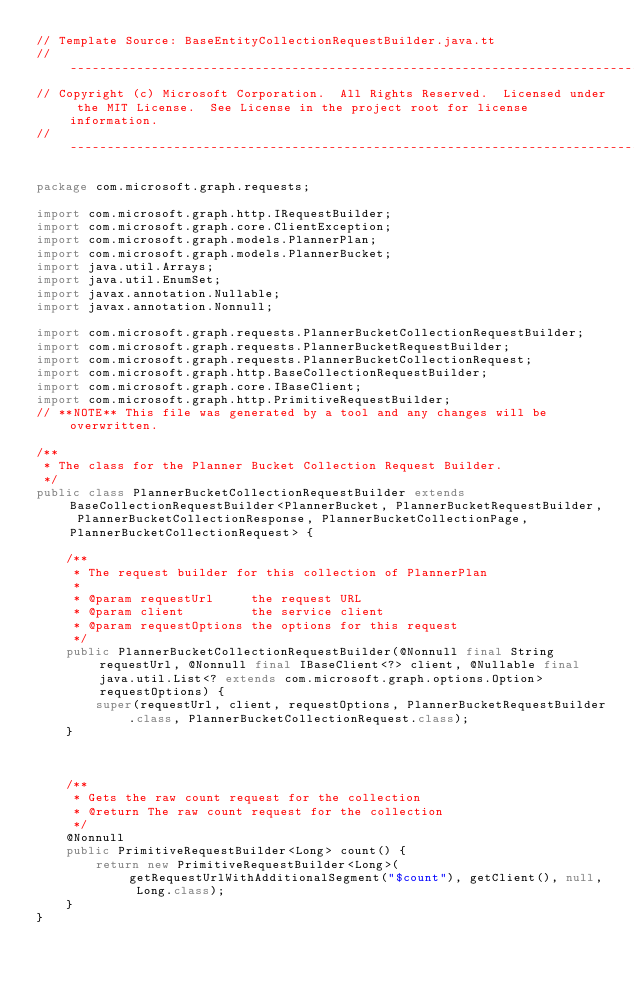<code> <loc_0><loc_0><loc_500><loc_500><_Java_>// Template Source: BaseEntityCollectionRequestBuilder.java.tt
// ------------------------------------------------------------------------------
// Copyright (c) Microsoft Corporation.  All Rights Reserved.  Licensed under the MIT License.  See License in the project root for license information.
// ------------------------------------------------------------------------------

package com.microsoft.graph.requests;

import com.microsoft.graph.http.IRequestBuilder;
import com.microsoft.graph.core.ClientException;
import com.microsoft.graph.models.PlannerPlan;
import com.microsoft.graph.models.PlannerBucket;
import java.util.Arrays;
import java.util.EnumSet;
import javax.annotation.Nullable;
import javax.annotation.Nonnull;

import com.microsoft.graph.requests.PlannerBucketCollectionRequestBuilder;
import com.microsoft.graph.requests.PlannerBucketRequestBuilder;
import com.microsoft.graph.requests.PlannerBucketCollectionRequest;
import com.microsoft.graph.http.BaseCollectionRequestBuilder;
import com.microsoft.graph.core.IBaseClient;
import com.microsoft.graph.http.PrimitiveRequestBuilder;
// **NOTE** This file was generated by a tool and any changes will be overwritten.

/**
 * The class for the Planner Bucket Collection Request Builder.
 */
public class PlannerBucketCollectionRequestBuilder extends BaseCollectionRequestBuilder<PlannerBucket, PlannerBucketRequestBuilder, PlannerBucketCollectionResponse, PlannerBucketCollectionPage, PlannerBucketCollectionRequest> {

    /**
     * The request builder for this collection of PlannerPlan
     *
     * @param requestUrl     the request URL
     * @param client         the service client
     * @param requestOptions the options for this request
     */
    public PlannerBucketCollectionRequestBuilder(@Nonnull final String requestUrl, @Nonnull final IBaseClient<?> client, @Nullable final java.util.List<? extends com.microsoft.graph.options.Option> requestOptions) {
        super(requestUrl, client, requestOptions, PlannerBucketRequestBuilder.class, PlannerBucketCollectionRequest.class);
    }



    /**
     * Gets the raw count request for the collection
     * @return The raw count request for the collection
     */
    @Nonnull
    public PrimitiveRequestBuilder<Long> count() {
        return new PrimitiveRequestBuilder<Long>(getRequestUrlWithAdditionalSegment("$count"), getClient(), null, Long.class);
    }
}
</code> 